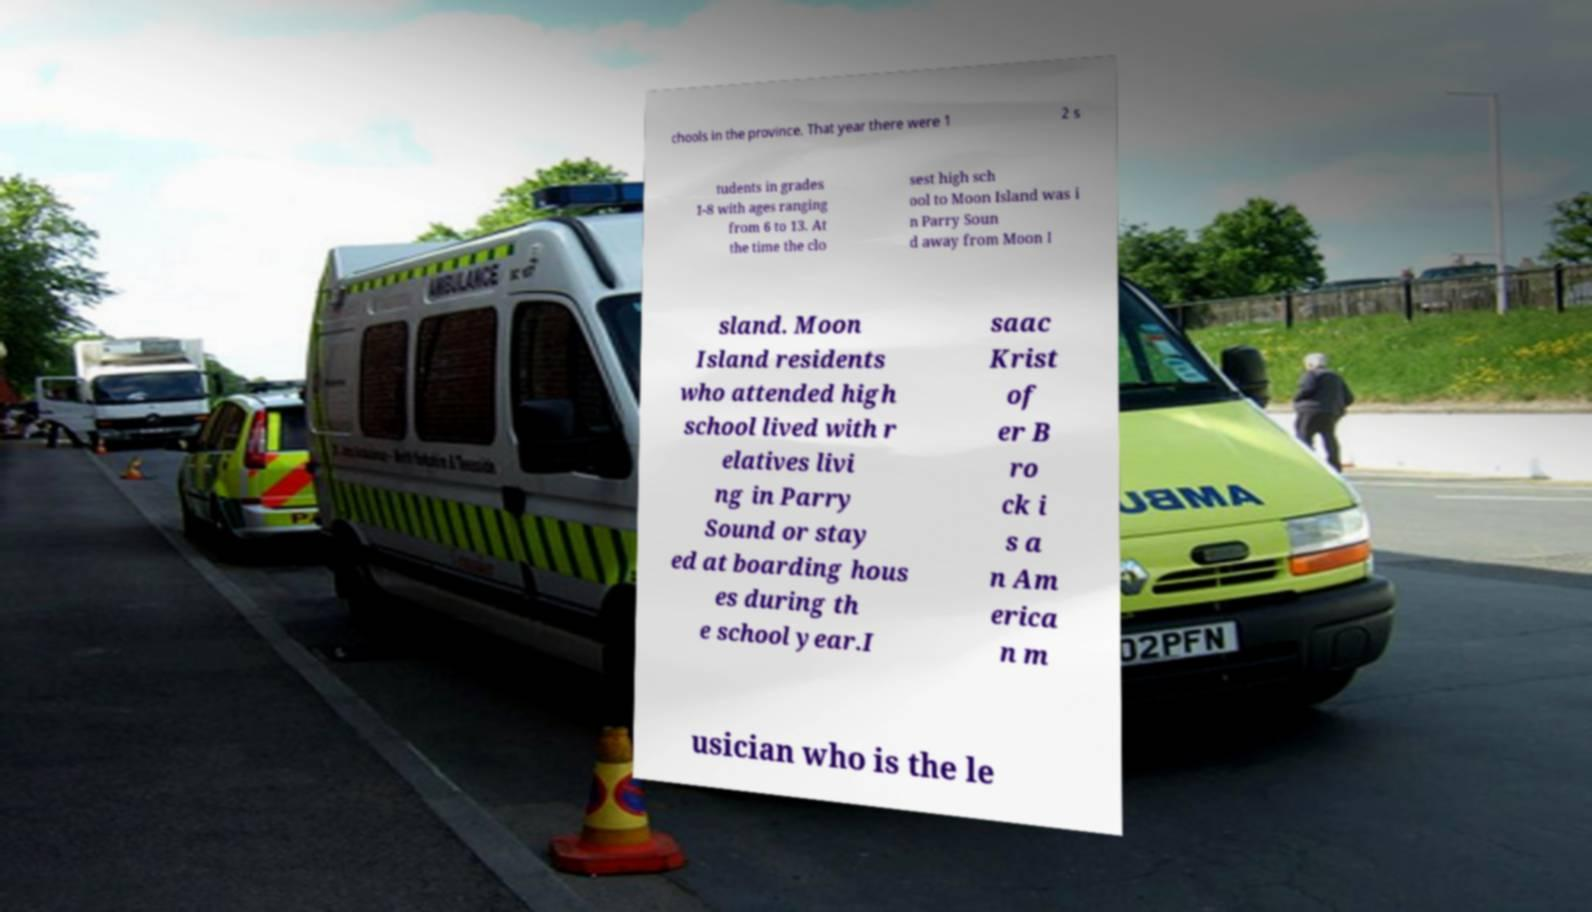For documentation purposes, I need the text within this image transcribed. Could you provide that? chools in the province. That year there were 1 2 s tudents in grades 1-8 with ages ranging from 6 to 13. At the time the clo sest high sch ool to Moon Island was i n Parry Soun d away from Moon I sland. Moon Island residents who attended high school lived with r elatives livi ng in Parry Sound or stay ed at boarding hous es during th e school year.I saac Krist of er B ro ck i s a n Am erica n m usician who is the le 